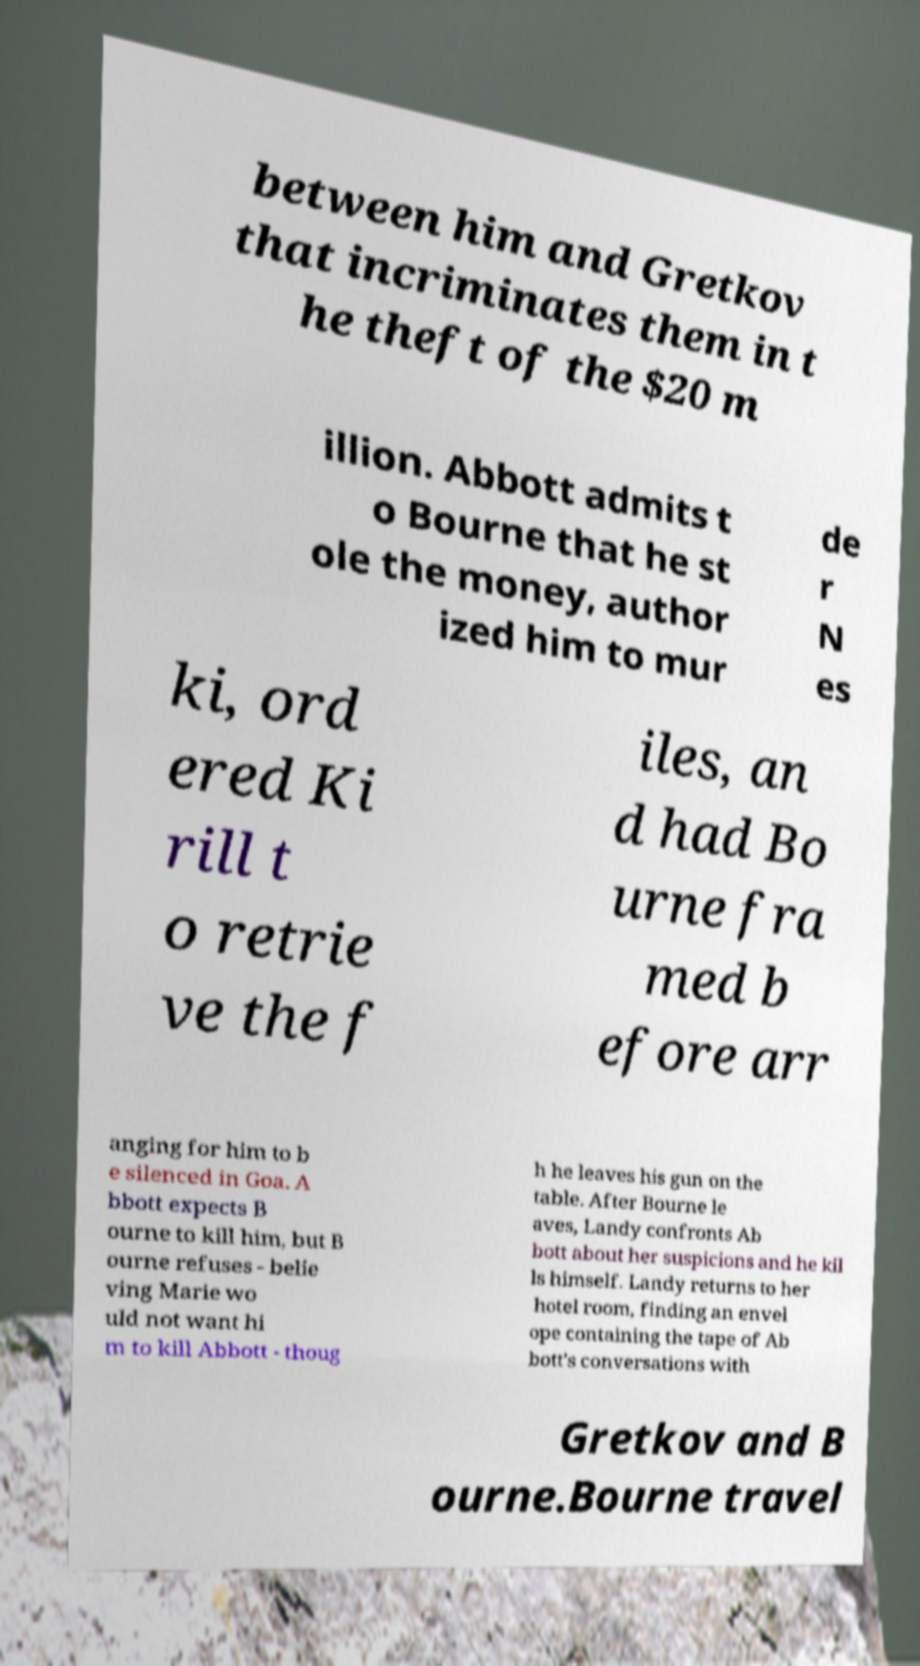I need the written content from this picture converted into text. Can you do that? between him and Gretkov that incriminates them in t he theft of the $20 m illion. Abbott admits t o Bourne that he st ole the money, author ized him to mur de r N es ki, ord ered Ki rill t o retrie ve the f iles, an d had Bo urne fra med b efore arr anging for him to b e silenced in Goa. A bbott expects B ourne to kill him, but B ourne refuses - belie ving Marie wo uld not want hi m to kill Abbott - thoug h he leaves his gun on the table. After Bourne le aves, Landy confronts Ab bott about her suspicions and he kil ls himself. Landy returns to her hotel room, finding an envel ope containing the tape of Ab bott's conversations with Gretkov and B ourne.Bourne travel 